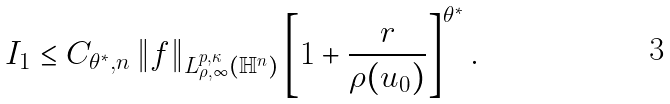Convert formula to latex. <formula><loc_0><loc_0><loc_500><loc_500>I _ { 1 } & \leq C _ { \theta ^ { * } , n } \left \| f \right \| _ { L ^ { p , \kappa } _ { \rho , \infty } ( \mathbb { H } ^ { n } ) } \left [ 1 + \frac { r } { \rho ( u _ { 0 } ) } \right ] ^ { \theta ^ { * } } .</formula> 